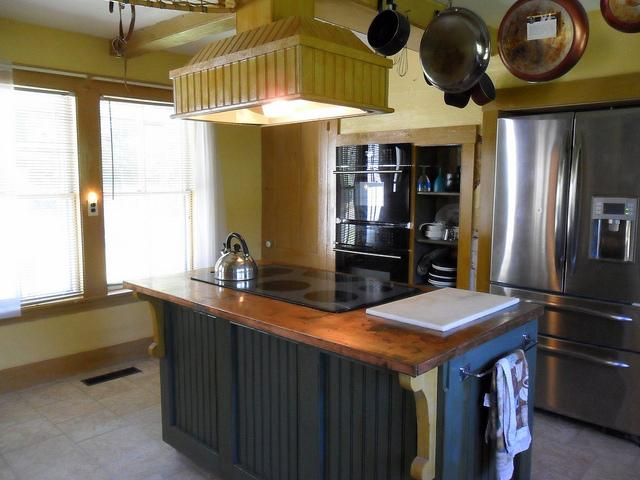What is the white rectangle on the island for? cutting 